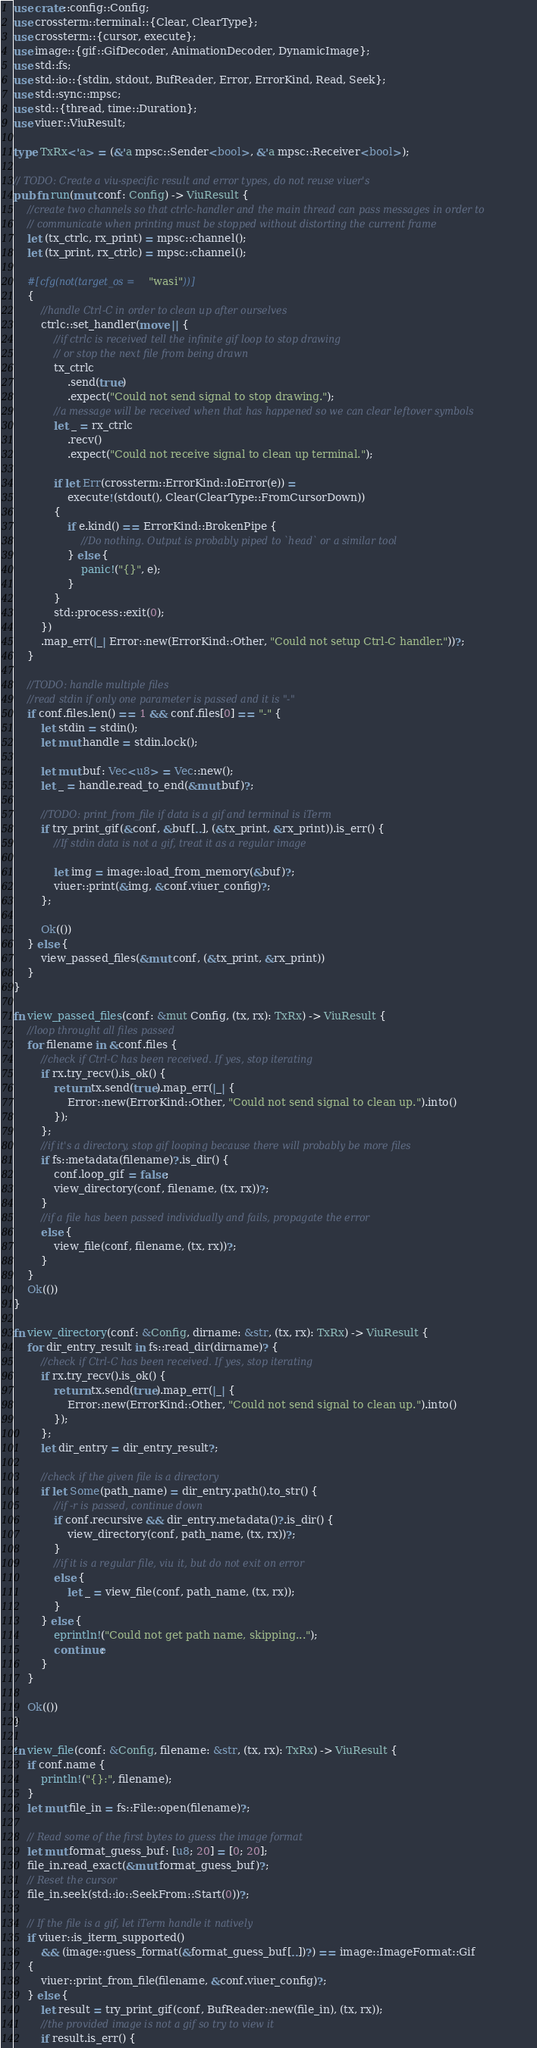Convert code to text. <code><loc_0><loc_0><loc_500><loc_500><_Rust_>use crate::config::Config;
use crossterm::terminal::{Clear, ClearType};
use crossterm::{cursor, execute};
use image::{gif::GifDecoder, AnimationDecoder, DynamicImage};
use std::fs;
use std::io::{stdin, stdout, BufReader, Error, ErrorKind, Read, Seek};
use std::sync::mpsc;
use std::{thread, time::Duration};
use viuer::ViuResult;

type TxRx<'a> = (&'a mpsc::Sender<bool>, &'a mpsc::Receiver<bool>);

// TODO: Create a viu-specific result and error types, do not reuse viuer's
pub fn run(mut conf: Config) -> ViuResult {
    //create two channels so that ctrlc-handler and the main thread can pass messages in order to
    // communicate when printing must be stopped without distorting the current frame
    let (tx_ctrlc, rx_print) = mpsc::channel();
    let (tx_print, rx_ctrlc) = mpsc::channel();

    #[cfg(not(target_os = "wasi"))]
    {
        //handle Ctrl-C in order to clean up after ourselves
        ctrlc::set_handler(move || {
            //if ctrlc is received tell the infinite gif loop to stop drawing
            // or stop the next file from being drawn
            tx_ctrlc
                .send(true)
                .expect("Could not send signal to stop drawing.");
            //a message will be received when that has happened so we can clear leftover symbols
            let _ = rx_ctrlc
                .recv()
                .expect("Could not receive signal to clean up terminal.");

            if let Err(crossterm::ErrorKind::IoError(e)) =
                execute!(stdout(), Clear(ClearType::FromCursorDown))
            {
                if e.kind() == ErrorKind::BrokenPipe {
                    //Do nothing. Output is probably piped to `head` or a similar tool
                } else {
                    panic!("{}", e);
                }
            }
            std::process::exit(0);
        })
        .map_err(|_| Error::new(ErrorKind::Other, "Could not setup Ctrl-C handler."))?;
    }

    //TODO: handle multiple files
    //read stdin if only one parameter is passed and it is "-"
    if conf.files.len() == 1 && conf.files[0] == "-" {
        let stdin = stdin();
        let mut handle = stdin.lock();

        let mut buf: Vec<u8> = Vec::new();
        let _ = handle.read_to_end(&mut buf)?;

        //TODO: print_from_file if data is a gif and terminal is iTerm
        if try_print_gif(&conf, &buf[..], (&tx_print, &rx_print)).is_err() {
            //If stdin data is not a gif, treat it as a regular image

            let img = image::load_from_memory(&buf)?;
            viuer::print(&img, &conf.viuer_config)?;
        };

        Ok(())
    } else {
        view_passed_files(&mut conf, (&tx_print, &rx_print))
    }
}

fn view_passed_files(conf: &mut Config, (tx, rx): TxRx) -> ViuResult {
    //loop throught all files passed
    for filename in &conf.files {
        //check if Ctrl-C has been received. If yes, stop iterating
        if rx.try_recv().is_ok() {
            return tx.send(true).map_err(|_| {
                Error::new(ErrorKind::Other, "Could not send signal to clean up.").into()
            });
        };
        //if it's a directory, stop gif looping because there will probably be more files
        if fs::metadata(filename)?.is_dir() {
            conf.loop_gif = false;
            view_directory(conf, filename, (tx, rx))?;
        }
        //if a file has been passed individually and fails, propagate the error
        else {
            view_file(conf, filename, (tx, rx))?;
        }
    }
    Ok(())
}

fn view_directory(conf: &Config, dirname: &str, (tx, rx): TxRx) -> ViuResult {
    for dir_entry_result in fs::read_dir(dirname)? {
        //check if Ctrl-C has been received. If yes, stop iterating
        if rx.try_recv().is_ok() {
            return tx.send(true).map_err(|_| {
                Error::new(ErrorKind::Other, "Could not send signal to clean up.").into()
            });
        };
        let dir_entry = dir_entry_result?;

        //check if the given file is a directory
        if let Some(path_name) = dir_entry.path().to_str() {
            //if -r is passed, continue down
            if conf.recursive && dir_entry.metadata()?.is_dir() {
                view_directory(conf, path_name, (tx, rx))?;
            }
            //if it is a regular file, viu it, but do not exit on error
            else {
                let _ = view_file(conf, path_name, (tx, rx));
            }
        } else {
            eprintln!("Could not get path name, skipping...");
            continue;
        }
    }

    Ok(())
}

fn view_file(conf: &Config, filename: &str, (tx, rx): TxRx) -> ViuResult {
    if conf.name {
        println!("{}:", filename);
    }
    let mut file_in = fs::File::open(filename)?;

    // Read some of the first bytes to guess the image format
    let mut format_guess_buf: [u8; 20] = [0; 20];
    file_in.read_exact(&mut format_guess_buf)?;
    // Reset the cursor
    file_in.seek(std::io::SeekFrom::Start(0))?;

    // If the file is a gif, let iTerm handle it natively
    if viuer::is_iterm_supported()
        && (image::guess_format(&format_guess_buf[..])?) == image::ImageFormat::Gif
    {
        viuer::print_from_file(filename, &conf.viuer_config)?;
    } else {
        let result = try_print_gif(conf, BufReader::new(file_in), (tx, rx));
        //the provided image is not a gif so try to view it
        if result.is_err() {</code> 